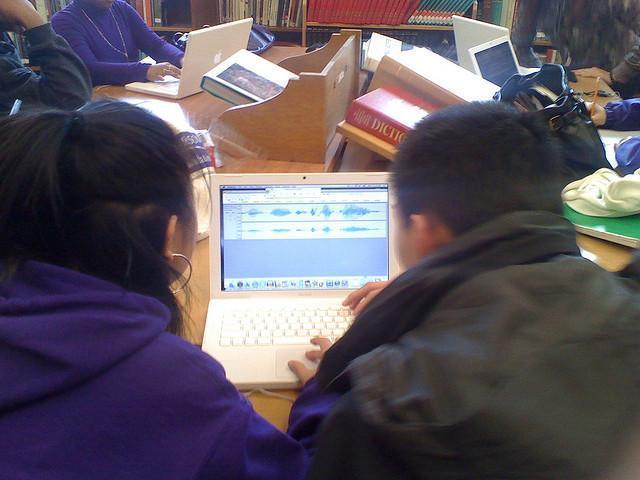Without the computers where would they look up definitions?
Answer the question by selecting the correct answer among the 4 following choices.
Options: Black book, green book, white book, red book. Red book. 